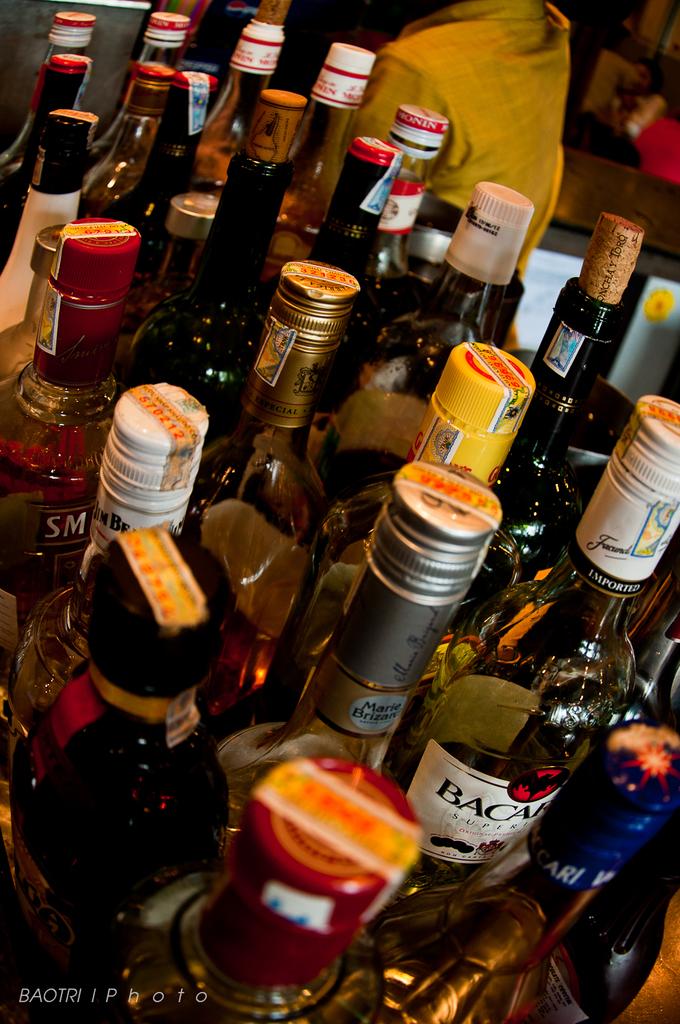What kind of liquor is there?
Offer a terse response. Bacardi. What brabd of rum is on the bottom right?
Make the answer very short. Bacardi. 